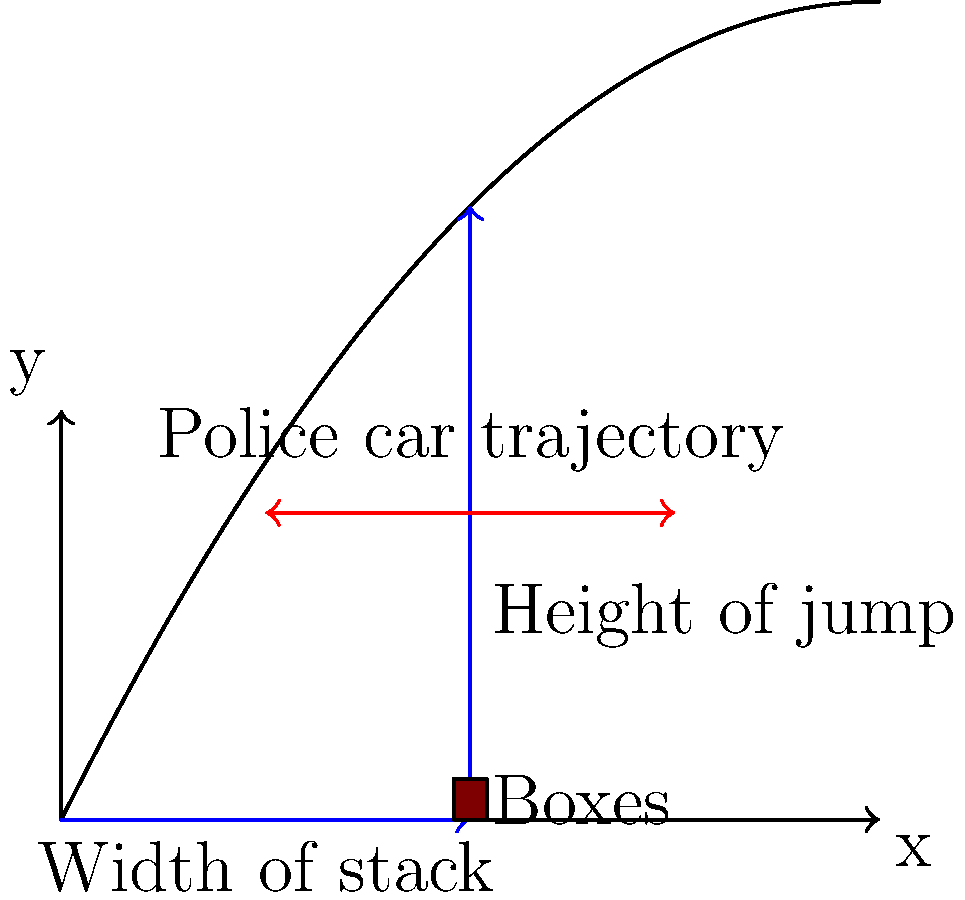Officer Chuckles is planning a daring stunt to impress the new recruits. He wants to jump his police car over a stack of cardboard boxes using a specially designed ramp. The trajectory of the car can be modeled by the polynomial function $f(x) = -0.1x^2 + 2x$, where $x$ is the horizontal distance from the start of the ramp (in meters) and $f(x)$ is the height of the car (in meters). If the stack of boxes is 5 meters wide, what is the maximum height of boxes that Officer Chuckles can safely clear? Let's approach this step-by-step:

1) The polynomial function describing the car's trajectory is $f(x) = -0.1x^2 + 2x$.

2) We need to find the maximum height of the car when it's directly over the stack of boxes. The stack is 5 meters wide, so we need to evaluate $f(5)$.

3) Let's calculate $f(5)$:
   $f(5) = -0.1(5^2) + 2(5)$
   $f(5) = -0.1(25) + 10$
   $f(5) = -2.5 + 10$
   $f(5) = 7.5$ meters

4) This means that at the 5-meter mark, the car will be at a height of 7.5 meters.

5) However, we need to consider a safety margin. It's generally recommended to have at least a 10% clearance for such stunts.

6) Let's calculate 90% of 7.5 meters:
   $7.5 * 0.9 = 6.75$ meters

Therefore, the maximum safe height for the stack of boxes would be 6.75 meters.
Answer: 6.75 meters 